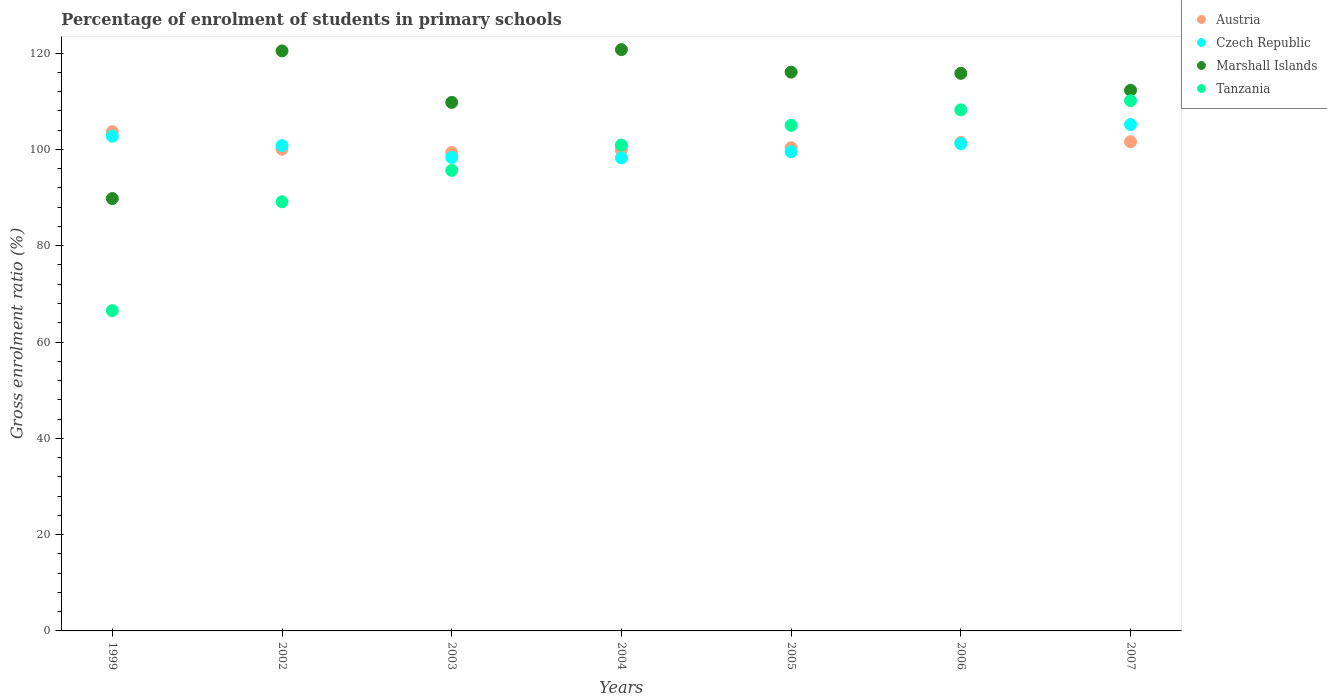Is the number of dotlines equal to the number of legend labels?
Offer a terse response. Yes. What is the percentage of students enrolled in primary schools in Czech Republic in 2004?
Make the answer very short. 98.23. Across all years, what is the maximum percentage of students enrolled in primary schools in Czech Republic?
Keep it short and to the point. 105.16. Across all years, what is the minimum percentage of students enrolled in primary schools in Czech Republic?
Your answer should be compact. 98.23. In which year was the percentage of students enrolled in primary schools in Czech Republic minimum?
Your response must be concise. 2004. What is the total percentage of students enrolled in primary schools in Tanzania in the graph?
Offer a terse response. 675.5. What is the difference between the percentage of students enrolled in primary schools in Austria in 2003 and that in 2006?
Offer a terse response. -2.08. What is the difference between the percentage of students enrolled in primary schools in Czech Republic in 2002 and the percentage of students enrolled in primary schools in Austria in 2005?
Keep it short and to the point. 0.46. What is the average percentage of students enrolled in primary schools in Tanzania per year?
Your answer should be compact. 96.5. In the year 2003, what is the difference between the percentage of students enrolled in primary schools in Austria and percentage of students enrolled in primary schools in Tanzania?
Offer a very short reply. 3.71. In how many years, is the percentage of students enrolled in primary schools in Czech Republic greater than 28 %?
Your answer should be very brief. 7. What is the ratio of the percentage of students enrolled in primary schools in Austria in 2005 to that in 2007?
Provide a short and direct response. 0.99. Is the difference between the percentage of students enrolled in primary schools in Austria in 2002 and 2007 greater than the difference between the percentage of students enrolled in primary schools in Tanzania in 2002 and 2007?
Ensure brevity in your answer.  Yes. What is the difference between the highest and the second highest percentage of students enrolled in primary schools in Tanzania?
Make the answer very short. 1.91. What is the difference between the highest and the lowest percentage of students enrolled in primary schools in Marshall Islands?
Your answer should be compact. 30.93. Is the sum of the percentage of students enrolled in primary schools in Tanzania in 2003 and 2004 greater than the maximum percentage of students enrolled in primary schools in Czech Republic across all years?
Ensure brevity in your answer.  Yes. Is it the case that in every year, the sum of the percentage of students enrolled in primary schools in Tanzania and percentage of students enrolled in primary schools in Austria  is greater than the sum of percentage of students enrolled in primary schools in Marshall Islands and percentage of students enrolled in primary schools in Czech Republic?
Offer a very short reply. No. Is it the case that in every year, the sum of the percentage of students enrolled in primary schools in Tanzania and percentage of students enrolled in primary schools in Austria  is greater than the percentage of students enrolled in primary schools in Czech Republic?
Make the answer very short. Yes. Does the percentage of students enrolled in primary schools in Czech Republic monotonically increase over the years?
Keep it short and to the point. No. Is the percentage of students enrolled in primary schools in Austria strictly greater than the percentage of students enrolled in primary schools in Marshall Islands over the years?
Ensure brevity in your answer.  No. Is the percentage of students enrolled in primary schools in Marshall Islands strictly less than the percentage of students enrolled in primary schools in Czech Republic over the years?
Ensure brevity in your answer.  No. How many dotlines are there?
Ensure brevity in your answer.  4. How many years are there in the graph?
Keep it short and to the point. 7. Are the values on the major ticks of Y-axis written in scientific E-notation?
Offer a terse response. No. Does the graph contain any zero values?
Provide a succinct answer. No. How many legend labels are there?
Make the answer very short. 4. What is the title of the graph?
Keep it short and to the point. Percentage of enrolment of students in primary schools. Does "Dominican Republic" appear as one of the legend labels in the graph?
Give a very brief answer. No. What is the label or title of the Y-axis?
Your answer should be very brief. Gross enrolment ratio (%). What is the Gross enrolment ratio (%) of Austria in 1999?
Give a very brief answer. 103.67. What is the Gross enrolment ratio (%) in Czech Republic in 1999?
Keep it short and to the point. 102.74. What is the Gross enrolment ratio (%) of Marshall Islands in 1999?
Make the answer very short. 89.79. What is the Gross enrolment ratio (%) of Tanzania in 1999?
Keep it short and to the point. 66.51. What is the Gross enrolment ratio (%) of Austria in 2002?
Your response must be concise. 100.04. What is the Gross enrolment ratio (%) in Czech Republic in 2002?
Provide a short and direct response. 100.79. What is the Gross enrolment ratio (%) in Marshall Islands in 2002?
Give a very brief answer. 120.45. What is the Gross enrolment ratio (%) in Tanzania in 2002?
Give a very brief answer. 89.12. What is the Gross enrolment ratio (%) in Austria in 2003?
Your response must be concise. 99.35. What is the Gross enrolment ratio (%) in Czech Republic in 2003?
Provide a short and direct response. 98.32. What is the Gross enrolment ratio (%) in Marshall Islands in 2003?
Your response must be concise. 109.76. What is the Gross enrolment ratio (%) in Tanzania in 2003?
Offer a very short reply. 95.65. What is the Gross enrolment ratio (%) of Austria in 2004?
Offer a very short reply. 99.85. What is the Gross enrolment ratio (%) of Czech Republic in 2004?
Ensure brevity in your answer.  98.23. What is the Gross enrolment ratio (%) of Marshall Islands in 2004?
Give a very brief answer. 120.72. What is the Gross enrolment ratio (%) of Tanzania in 2004?
Your answer should be very brief. 100.91. What is the Gross enrolment ratio (%) in Austria in 2005?
Ensure brevity in your answer.  100.33. What is the Gross enrolment ratio (%) of Czech Republic in 2005?
Offer a very short reply. 99.52. What is the Gross enrolment ratio (%) in Marshall Islands in 2005?
Make the answer very short. 116.05. What is the Gross enrolment ratio (%) of Tanzania in 2005?
Keep it short and to the point. 104.99. What is the Gross enrolment ratio (%) in Austria in 2006?
Your answer should be very brief. 101.43. What is the Gross enrolment ratio (%) of Czech Republic in 2006?
Your answer should be compact. 101.2. What is the Gross enrolment ratio (%) in Marshall Islands in 2006?
Ensure brevity in your answer.  115.79. What is the Gross enrolment ratio (%) of Tanzania in 2006?
Your answer should be very brief. 108.21. What is the Gross enrolment ratio (%) in Austria in 2007?
Ensure brevity in your answer.  101.59. What is the Gross enrolment ratio (%) of Czech Republic in 2007?
Keep it short and to the point. 105.16. What is the Gross enrolment ratio (%) in Marshall Islands in 2007?
Offer a terse response. 112.27. What is the Gross enrolment ratio (%) in Tanzania in 2007?
Provide a short and direct response. 110.12. Across all years, what is the maximum Gross enrolment ratio (%) in Austria?
Ensure brevity in your answer.  103.67. Across all years, what is the maximum Gross enrolment ratio (%) of Czech Republic?
Provide a short and direct response. 105.16. Across all years, what is the maximum Gross enrolment ratio (%) of Marshall Islands?
Give a very brief answer. 120.72. Across all years, what is the maximum Gross enrolment ratio (%) in Tanzania?
Offer a terse response. 110.12. Across all years, what is the minimum Gross enrolment ratio (%) of Austria?
Your response must be concise. 99.35. Across all years, what is the minimum Gross enrolment ratio (%) in Czech Republic?
Offer a terse response. 98.23. Across all years, what is the minimum Gross enrolment ratio (%) of Marshall Islands?
Your answer should be very brief. 89.79. Across all years, what is the minimum Gross enrolment ratio (%) in Tanzania?
Keep it short and to the point. 66.51. What is the total Gross enrolment ratio (%) of Austria in the graph?
Offer a very short reply. 706.27. What is the total Gross enrolment ratio (%) in Czech Republic in the graph?
Provide a succinct answer. 705.97. What is the total Gross enrolment ratio (%) of Marshall Islands in the graph?
Your response must be concise. 784.84. What is the total Gross enrolment ratio (%) in Tanzania in the graph?
Provide a short and direct response. 675.5. What is the difference between the Gross enrolment ratio (%) of Austria in 1999 and that in 2002?
Offer a very short reply. 3.63. What is the difference between the Gross enrolment ratio (%) in Czech Republic in 1999 and that in 2002?
Offer a terse response. 1.95. What is the difference between the Gross enrolment ratio (%) of Marshall Islands in 1999 and that in 2002?
Keep it short and to the point. -30.66. What is the difference between the Gross enrolment ratio (%) in Tanzania in 1999 and that in 2002?
Provide a short and direct response. -22.62. What is the difference between the Gross enrolment ratio (%) in Austria in 1999 and that in 2003?
Make the answer very short. 4.32. What is the difference between the Gross enrolment ratio (%) of Czech Republic in 1999 and that in 2003?
Offer a very short reply. 4.42. What is the difference between the Gross enrolment ratio (%) of Marshall Islands in 1999 and that in 2003?
Your answer should be very brief. -19.97. What is the difference between the Gross enrolment ratio (%) of Tanzania in 1999 and that in 2003?
Offer a terse response. -29.14. What is the difference between the Gross enrolment ratio (%) of Austria in 1999 and that in 2004?
Your answer should be compact. 3.82. What is the difference between the Gross enrolment ratio (%) in Czech Republic in 1999 and that in 2004?
Keep it short and to the point. 4.51. What is the difference between the Gross enrolment ratio (%) in Marshall Islands in 1999 and that in 2004?
Provide a short and direct response. -30.93. What is the difference between the Gross enrolment ratio (%) in Tanzania in 1999 and that in 2004?
Your answer should be very brief. -34.4. What is the difference between the Gross enrolment ratio (%) of Austria in 1999 and that in 2005?
Your response must be concise. 3.34. What is the difference between the Gross enrolment ratio (%) of Czech Republic in 1999 and that in 2005?
Your response must be concise. 3.22. What is the difference between the Gross enrolment ratio (%) in Marshall Islands in 1999 and that in 2005?
Your response must be concise. -26.26. What is the difference between the Gross enrolment ratio (%) of Tanzania in 1999 and that in 2005?
Provide a short and direct response. -38.49. What is the difference between the Gross enrolment ratio (%) of Austria in 1999 and that in 2006?
Your answer should be very brief. 2.24. What is the difference between the Gross enrolment ratio (%) in Czech Republic in 1999 and that in 2006?
Make the answer very short. 1.55. What is the difference between the Gross enrolment ratio (%) of Marshall Islands in 1999 and that in 2006?
Ensure brevity in your answer.  -26. What is the difference between the Gross enrolment ratio (%) in Tanzania in 1999 and that in 2006?
Provide a short and direct response. -41.7. What is the difference between the Gross enrolment ratio (%) in Austria in 1999 and that in 2007?
Make the answer very short. 2.08. What is the difference between the Gross enrolment ratio (%) in Czech Republic in 1999 and that in 2007?
Provide a short and direct response. -2.42. What is the difference between the Gross enrolment ratio (%) in Marshall Islands in 1999 and that in 2007?
Provide a short and direct response. -22.48. What is the difference between the Gross enrolment ratio (%) of Tanzania in 1999 and that in 2007?
Make the answer very short. -43.61. What is the difference between the Gross enrolment ratio (%) of Austria in 2002 and that in 2003?
Your response must be concise. 0.69. What is the difference between the Gross enrolment ratio (%) of Czech Republic in 2002 and that in 2003?
Your answer should be very brief. 2.47. What is the difference between the Gross enrolment ratio (%) of Marshall Islands in 2002 and that in 2003?
Your response must be concise. 10.69. What is the difference between the Gross enrolment ratio (%) of Tanzania in 2002 and that in 2003?
Give a very brief answer. -6.52. What is the difference between the Gross enrolment ratio (%) in Austria in 2002 and that in 2004?
Make the answer very short. 0.19. What is the difference between the Gross enrolment ratio (%) of Czech Republic in 2002 and that in 2004?
Give a very brief answer. 2.56. What is the difference between the Gross enrolment ratio (%) in Marshall Islands in 2002 and that in 2004?
Ensure brevity in your answer.  -0.27. What is the difference between the Gross enrolment ratio (%) in Tanzania in 2002 and that in 2004?
Make the answer very short. -11.78. What is the difference between the Gross enrolment ratio (%) of Austria in 2002 and that in 2005?
Give a very brief answer. -0.29. What is the difference between the Gross enrolment ratio (%) in Czech Republic in 2002 and that in 2005?
Keep it short and to the point. 1.27. What is the difference between the Gross enrolment ratio (%) in Marshall Islands in 2002 and that in 2005?
Make the answer very short. 4.4. What is the difference between the Gross enrolment ratio (%) in Tanzania in 2002 and that in 2005?
Keep it short and to the point. -15.87. What is the difference between the Gross enrolment ratio (%) of Austria in 2002 and that in 2006?
Provide a short and direct response. -1.39. What is the difference between the Gross enrolment ratio (%) of Czech Republic in 2002 and that in 2006?
Give a very brief answer. -0.41. What is the difference between the Gross enrolment ratio (%) of Marshall Islands in 2002 and that in 2006?
Provide a succinct answer. 4.66. What is the difference between the Gross enrolment ratio (%) of Tanzania in 2002 and that in 2006?
Provide a succinct answer. -19.08. What is the difference between the Gross enrolment ratio (%) of Austria in 2002 and that in 2007?
Keep it short and to the point. -1.55. What is the difference between the Gross enrolment ratio (%) of Czech Republic in 2002 and that in 2007?
Offer a very short reply. -4.37. What is the difference between the Gross enrolment ratio (%) of Marshall Islands in 2002 and that in 2007?
Keep it short and to the point. 8.18. What is the difference between the Gross enrolment ratio (%) of Tanzania in 2002 and that in 2007?
Provide a succinct answer. -21. What is the difference between the Gross enrolment ratio (%) of Austria in 2003 and that in 2004?
Make the answer very short. -0.5. What is the difference between the Gross enrolment ratio (%) of Czech Republic in 2003 and that in 2004?
Provide a succinct answer. 0.09. What is the difference between the Gross enrolment ratio (%) in Marshall Islands in 2003 and that in 2004?
Give a very brief answer. -10.96. What is the difference between the Gross enrolment ratio (%) in Tanzania in 2003 and that in 2004?
Provide a succinct answer. -5.26. What is the difference between the Gross enrolment ratio (%) of Austria in 2003 and that in 2005?
Ensure brevity in your answer.  -0.98. What is the difference between the Gross enrolment ratio (%) of Czech Republic in 2003 and that in 2005?
Offer a terse response. -1.2. What is the difference between the Gross enrolment ratio (%) of Marshall Islands in 2003 and that in 2005?
Give a very brief answer. -6.29. What is the difference between the Gross enrolment ratio (%) of Tanzania in 2003 and that in 2005?
Your response must be concise. -9.35. What is the difference between the Gross enrolment ratio (%) in Austria in 2003 and that in 2006?
Offer a terse response. -2.08. What is the difference between the Gross enrolment ratio (%) of Czech Republic in 2003 and that in 2006?
Your response must be concise. -2.87. What is the difference between the Gross enrolment ratio (%) of Marshall Islands in 2003 and that in 2006?
Your answer should be very brief. -6.03. What is the difference between the Gross enrolment ratio (%) of Tanzania in 2003 and that in 2006?
Offer a terse response. -12.56. What is the difference between the Gross enrolment ratio (%) in Austria in 2003 and that in 2007?
Ensure brevity in your answer.  -2.23. What is the difference between the Gross enrolment ratio (%) in Czech Republic in 2003 and that in 2007?
Ensure brevity in your answer.  -6.84. What is the difference between the Gross enrolment ratio (%) in Marshall Islands in 2003 and that in 2007?
Your answer should be compact. -2.51. What is the difference between the Gross enrolment ratio (%) of Tanzania in 2003 and that in 2007?
Make the answer very short. -14.47. What is the difference between the Gross enrolment ratio (%) of Austria in 2004 and that in 2005?
Provide a short and direct response. -0.48. What is the difference between the Gross enrolment ratio (%) of Czech Republic in 2004 and that in 2005?
Keep it short and to the point. -1.29. What is the difference between the Gross enrolment ratio (%) in Marshall Islands in 2004 and that in 2005?
Ensure brevity in your answer.  4.67. What is the difference between the Gross enrolment ratio (%) of Tanzania in 2004 and that in 2005?
Your response must be concise. -4.09. What is the difference between the Gross enrolment ratio (%) in Austria in 2004 and that in 2006?
Ensure brevity in your answer.  -1.58. What is the difference between the Gross enrolment ratio (%) of Czech Republic in 2004 and that in 2006?
Give a very brief answer. -2.97. What is the difference between the Gross enrolment ratio (%) in Marshall Islands in 2004 and that in 2006?
Ensure brevity in your answer.  4.93. What is the difference between the Gross enrolment ratio (%) of Tanzania in 2004 and that in 2006?
Your answer should be compact. -7.3. What is the difference between the Gross enrolment ratio (%) of Austria in 2004 and that in 2007?
Your answer should be compact. -1.73. What is the difference between the Gross enrolment ratio (%) of Czech Republic in 2004 and that in 2007?
Your answer should be compact. -6.93. What is the difference between the Gross enrolment ratio (%) of Marshall Islands in 2004 and that in 2007?
Provide a succinct answer. 8.45. What is the difference between the Gross enrolment ratio (%) of Tanzania in 2004 and that in 2007?
Make the answer very short. -9.21. What is the difference between the Gross enrolment ratio (%) of Austria in 2005 and that in 2006?
Make the answer very short. -1.1. What is the difference between the Gross enrolment ratio (%) of Czech Republic in 2005 and that in 2006?
Keep it short and to the point. -1.68. What is the difference between the Gross enrolment ratio (%) in Marshall Islands in 2005 and that in 2006?
Provide a short and direct response. 0.26. What is the difference between the Gross enrolment ratio (%) in Tanzania in 2005 and that in 2006?
Make the answer very short. -3.21. What is the difference between the Gross enrolment ratio (%) of Austria in 2005 and that in 2007?
Offer a terse response. -1.25. What is the difference between the Gross enrolment ratio (%) of Czech Republic in 2005 and that in 2007?
Keep it short and to the point. -5.64. What is the difference between the Gross enrolment ratio (%) of Marshall Islands in 2005 and that in 2007?
Your response must be concise. 3.78. What is the difference between the Gross enrolment ratio (%) in Tanzania in 2005 and that in 2007?
Give a very brief answer. -5.13. What is the difference between the Gross enrolment ratio (%) of Austria in 2006 and that in 2007?
Your response must be concise. -0.15. What is the difference between the Gross enrolment ratio (%) of Czech Republic in 2006 and that in 2007?
Make the answer very short. -3.96. What is the difference between the Gross enrolment ratio (%) of Marshall Islands in 2006 and that in 2007?
Your answer should be compact. 3.52. What is the difference between the Gross enrolment ratio (%) of Tanzania in 2006 and that in 2007?
Give a very brief answer. -1.91. What is the difference between the Gross enrolment ratio (%) in Austria in 1999 and the Gross enrolment ratio (%) in Czech Republic in 2002?
Provide a short and direct response. 2.88. What is the difference between the Gross enrolment ratio (%) of Austria in 1999 and the Gross enrolment ratio (%) of Marshall Islands in 2002?
Provide a succinct answer. -16.78. What is the difference between the Gross enrolment ratio (%) in Austria in 1999 and the Gross enrolment ratio (%) in Tanzania in 2002?
Your response must be concise. 14.55. What is the difference between the Gross enrolment ratio (%) in Czech Republic in 1999 and the Gross enrolment ratio (%) in Marshall Islands in 2002?
Your response must be concise. -17.71. What is the difference between the Gross enrolment ratio (%) of Czech Republic in 1999 and the Gross enrolment ratio (%) of Tanzania in 2002?
Give a very brief answer. 13.62. What is the difference between the Gross enrolment ratio (%) of Marshall Islands in 1999 and the Gross enrolment ratio (%) of Tanzania in 2002?
Your answer should be very brief. 0.67. What is the difference between the Gross enrolment ratio (%) in Austria in 1999 and the Gross enrolment ratio (%) in Czech Republic in 2003?
Your answer should be very brief. 5.35. What is the difference between the Gross enrolment ratio (%) in Austria in 1999 and the Gross enrolment ratio (%) in Marshall Islands in 2003?
Your response must be concise. -6.09. What is the difference between the Gross enrolment ratio (%) of Austria in 1999 and the Gross enrolment ratio (%) of Tanzania in 2003?
Keep it short and to the point. 8.03. What is the difference between the Gross enrolment ratio (%) in Czech Republic in 1999 and the Gross enrolment ratio (%) in Marshall Islands in 2003?
Your answer should be very brief. -7.02. What is the difference between the Gross enrolment ratio (%) in Czech Republic in 1999 and the Gross enrolment ratio (%) in Tanzania in 2003?
Provide a succinct answer. 7.1. What is the difference between the Gross enrolment ratio (%) in Marshall Islands in 1999 and the Gross enrolment ratio (%) in Tanzania in 2003?
Offer a very short reply. -5.85. What is the difference between the Gross enrolment ratio (%) in Austria in 1999 and the Gross enrolment ratio (%) in Czech Republic in 2004?
Offer a very short reply. 5.44. What is the difference between the Gross enrolment ratio (%) in Austria in 1999 and the Gross enrolment ratio (%) in Marshall Islands in 2004?
Provide a short and direct response. -17.05. What is the difference between the Gross enrolment ratio (%) of Austria in 1999 and the Gross enrolment ratio (%) of Tanzania in 2004?
Your answer should be compact. 2.76. What is the difference between the Gross enrolment ratio (%) of Czech Republic in 1999 and the Gross enrolment ratio (%) of Marshall Islands in 2004?
Offer a very short reply. -17.98. What is the difference between the Gross enrolment ratio (%) of Czech Republic in 1999 and the Gross enrolment ratio (%) of Tanzania in 2004?
Make the answer very short. 1.84. What is the difference between the Gross enrolment ratio (%) of Marshall Islands in 1999 and the Gross enrolment ratio (%) of Tanzania in 2004?
Provide a succinct answer. -11.11. What is the difference between the Gross enrolment ratio (%) of Austria in 1999 and the Gross enrolment ratio (%) of Czech Republic in 2005?
Make the answer very short. 4.15. What is the difference between the Gross enrolment ratio (%) of Austria in 1999 and the Gross enrolment ratio (%) of Marshall Islands in 2005?
Offer a very short reply. -12.38. What is the difference between the Gross enrolment ratio (%) in Austria in 1999 and the Gross enrolment ratio (%) in Tanzania in 2005?
Your answer should be compact. -1.32. What is the difference between the Gross enrolment ratio (%) of Czech Republic in 1999 and the Gross enrolment ratio (%) of Marshall Islands in 2005?
Keep it short and to the point. -13.31. What is the difference between the Gross enrolment ratio (%) of Czech Republic in 1999 and the Gross enrolment ratio (%) of Tanzania in 2005?
Keep it short and to the point. -2.25. What is the difference between the Gross enrolment ratio (%) of Marshall Islands in 1999 and the Gross enrolment ratio (%) of Tanzania in 2005?
Make the answer very short. -15.2. What is the difference between the Gross enrolment ratio (%) in Austria in 1999 and the Gross enrolment ratio (%) in Czech Republic in 2006?
Your answer should be very brief. 2.47. What is the difference between the Gross enrolment ratio (%) of Austria in 1999 and the Gross enrolment ratio (%) of Marshall Islands in 2006?
Ensure brevity in your answer.  -12.12. What is the difference between the Gross enrolment ratio (%) of Austria in 1999 and the Gross enrolment ratio (%) of Tanzania in 2006?
Your answer should be compact. -4.54. What is the difference between the Gross enrolment ratio (%) of Czech Republic in 1999 and the Gross enrolment ratio (%) of Marshall Islands in 2006?
Make the answer very short. -13.05. What is the difference between the Gross enrolment ratio (%) in Czech Republic in 1999 and the Gross enrolment ratio (%) in Tanzania in 2006?
Your answer should be compact. -5.46. What is the difference between the Gross enrolment ratio (%) in Marshall Islands in 1999 and the Gross enrolment ratio (%) in Tanzania in 2006?
Give a very brief answer. -18.41. What is the difference between the Gross enrolment ratio (%) in Austria in 1999 and the Gross enrolment ratio (%) in Czech Republic in 2007?
Your answer should be compact. -1.49. What is the difference between the Gross enrolment ratio (%) in Austria in 1999 and the Gross enrolment ratio (%) in Marshall Islands in 2007?
Provide a succinct answer. -8.6. What is the difference between the Gross enrolment ratio (%) in Austria in 1999 and the Gross enrolment ratio (%) in Tanzania in 2007?
Your answer should be compact. -6.45. What is the difference between the Gross enrolment ratio (%) of Czech Republic in 1999 and the Gross enrolment ratio (%) of Marshall Islands in 2007?
Give a very brief answer. -9.53. What is the difference between the Gross enrolment ratio (%) of Czech Republic in 1999 and the Gross enrolment ratio (%) of Tanzania in 2007?
Ensure brevity in your answer.  -7.37. What is the difference between the Gross enrolment ratio (%) of Marshall Islands in 1999 and the Gross enrolment ratio (%) of Tanzania in 2007?
Your answer should be compact. -20.32. What is the difference between the Gross enrolment ratio (%) of Austria in 2002 and the Gross enrolment ratio (%) of Czech Republic in 2003?
Your answer should be very brief. 1.72. What is the difference between the Gross enrolment ratio (%) in Austria in 2002 and the Gross enrolment ratio (%) in Marshall Islands in 2003?
Your answer should be compact. -9.72. What is the difference between the Gross enrolment ratio (%) in Austria in 2002 and the Gross enrolment ratio (%) in Tanzania in 2003?
Give a very brief answer. 4.39. What is the difference between the Gross enrolment ratio (%) of Czech Republic in 2002 and the Gross enrolment ratio (%) of Marshall Islands in 2003?
Your answer should be compact. -8.97. What is the difference between the Gross enrolment ratio (%) of Czech Republic in 2002 and the Gross enrolment ratio (%) of Tanzania in 2003?
Offer a very short reply. 5.14. What is the difference between the Gross enrolment ratio (%) of Marshall Islands in 2002 and the Gross enrolment ratio (%) of Tanzania in 2003?
Offer a very short reply. 24.81. What is the difference between the Gross enrolment ratio (%) in Austria in 2002 and the Gross enrolment ratio (%) in Czech Republic in 2004?
Provide a short and direct response. 1.81. What is the difference between the Gross enrolment ratio (%) of Austria in 2002 and the Gross enrolment ratio (%) of Marshall Islands in 2004?
Provide a succinct answer. -20.68. What is the difference between the Gross enrolment ratio (%) of Austria in 2002 and the Gross enrolment ratio (%) of Tanzania in 2004?
Provide a succinct answer. -0.87. What is the difference between the Gross enrolment ratio (%) of Czech Republic in 2002 and the Gross enrolment ratio (%) of Marshall Islands in 2004?
Make the answer very short. -19.93. What is the difference between the Gross enrolment ratio (%) in Czech Republic in 2002 and the Gross enrolment ratio (%) in Tanzania in 2004?
Your response must be concise. -0.12. What is the difference between the Gross enrolment ratio (%) of Marshall Islands in 2002 and the Gross enrolment ratio (%) of Tanzania in 2004?
Offer a very short reply. 19.55. What is the difference between the Gross enrolment ratio (%) in Austria in 2002 and the Gross enrolment ratio (%) in Czech Republic in 2005?
Your answer should be compact. 0.52. What is the difference between the Gross enrolment ratio (%) in Austria in 2002 and the Gross enrolment ratio (%) in Marshall Islands in 2005?
Keep it short and to the point. -16.01. What is the difference between the Gross enrolment ratio (%) of Austria in 2002 and the Gross enrolment ratio (%) of Tanzania in 2005?
Provide a short and direct response. -4.95. What is the difference between the Gross enrolment ratio (%) in Czech Republic in 2002 and the Gross enrolment ratio (%) in Marshall Islands in 2005?
Provide a succinct answer. -15.26. What is the difference between the Gross enrolment ratio (%) in Czech Republic in 2002 and the Gross enrolment ratio (%) in Tanzania in 2005?
Offer a very short reply. -4.2. What is the difference between the Gross enrolment ratio (%) of Marshall Islands in 2002 and the Gross enrolment ratio (%) of Tanzania in 2005?
Give a very brief answer. 15.46. What is the difference between the Gross enrolment ratio (%) of Austria in 2002 and the Gross enrolment ratio (%) of Czech Republic in 2006?
Offer a very short reply. -1.16. What is the difference between the Gross enrolment ratio (%) in Austria in 2002 and the Gross enrolment ratio (%) in Marshall Islands in 2006?
Your response must be concise. -15.75. What is the difference between the Gross enrolment ratio (%) in Austria in 2002 and the Gross enrolment ratio (%) in Tanzania in 2006?
Keep it short and to the point. -8.17. What is the difference between the Gross enrolment ratio (%) in Czech Republic in 2002 and the Gross enrolment ratio (%) in Marshall Islands in 2006?
Offer a very short reply. -15. What is the difference between the Gross enrolment ratio (%) of Czech Republic in 2002 and the Gross enrolment ratio (%) of Tanzania in 2006?
Your answer should be very brief. -7.42. What is the difference between the Gross enrolment ratio (%) of Marshall Islands in 2002 and the Gross enrolment ratio (%) of Tanzania in 2006?
Your answer should be very brief. 12.25. What is the difference between the Gross enrolment ratio (%) of Austria in 2002 and the Gross enrolment ratio (%) of Czech Republic in 2007?
Offer a terse response. -5.12. What is the difference between the Gross enrolment ratio (%) of Austria in 2002 and the Gross enrolment ratio (%) of Marshall Islands in 2007?
Keep it short and to the point. -12.23. What is the difference between the Gross enrolment ratio (%) in Austria in 2002 and the Gross enrolment ratio (%) in Tanzania in 2007?
Make the answer very short. -10.08. What is the difference between the Gross enrolment ratio (%) of Czech Republic in 2002 and the Gross enrolment ratio (%) of Marshall Islands in 2007?
Make the answer very short. -11.48. What is the difference between the Gross enrolment ratio (%) of Czech Republic in 2002 and the Gross enrolment ratio (%) of Tanzania in 2007?
Provide a short and direct response. -9.33. What is the difference between the Gross enrolment ratio (%) of Marshall Islands in 2002 and the Gross enrolment ratio (%) of Tanzania in 2007?
Your answer should be compact. 10.34. What is the difference between the Gross enrolment ratio (%) in Austria in 2003 and the Gross enrolment ratio (%) in Czech Republic in 2004?
Your answer should be compact. 1.12. What is the difference between the Gross enrolment ratio (%) of Austria in 2003 and the Gross enrolment ratio (%) of Marshall Islands in 2004?
Your answer should be compact. -21.37. What is the difference between the Gross enrolment ratio (%) of Austria in 2003 and the Gross enrolment ratio (%) of Tanzania in 2004?
Offer a terse response. -1.55. What is the difference between the Gross enrolment ratio (%) of Czech Republic in 2003 and the Gross enrolment ratio (%) of Marshall Islands in 2004?
Provide a short and direct response. -22.4. What is the difference between the Gross enrolment ratio (%) of Czech Republic in 2003 and the Gross enrolment ratio (%) of Tanzania in 2004?
Offer a terse response. -2.58. What is the difference between the Gross enrolment ratio (%) in Marshall Islands in 2003 and the Gross enrolment ratio (%) in Tanzania in 2004?
Keep it short and to the point. 8.85. What is the difference between the Gross enrolment ratio (%) of Austria in 2003 and the Gross enrolment ratio (%) of Czech Republic in 2005?
Provide a succinct answer. -0.17. What is the difference between the Gross enrolment ratio (%) of Austria in 2003 and the Gross enrolment ratio (%) of Marshall Islands in 2005?
Offer a terse response. -16.7. What is the difference between the Gross enrolment ratio (%) in Austria in 2003 and the Gross enrolment ratio (%) in Tanzania in 2005?
Keep it short and to the point. -5.64. What is the difference between the Gross enrolment ratio (%) in Czech Republic in 2003 and the Gross enrolment ratio (%) in Marshall Islands in 2005?
Your answer should be compact. -17.73. What is the difference between the Gross enrolment ratio (%) in Czech Republic in 2003 and the Gross enrolment ratio (%) in Tanzania in 2005?
Provide a succinct answer. -6.67. What is the difference between the Gross enrolment ratio (%) of Marshall Islands in 2003 and the Gross enrolment ratio (%) of Tanzania in 2005?
Make the answer very short. 4.77. What is the difference between the Gross enrolment ratio (%) in Austria in 2003 and the Gross enrolment ratio (%) in Czech Republic in 2006?
Give a very brief answer. -1.84. What is the difference between the Gross enrolment ratio (%) in Austria in 2003 and the Gross enrolment ratio (%) in Marshall Islands in 2006?
Give a very brief answer. -16.44. What is the difference between the Gross enrolment ratio (%) in Austria in 2003 and the Gross enrolment ratio (%) in Tanzania in 2006?
Your response must be concise. -8.85. What is the difference between the Gross enrolment ratio (%) of Czech Republic in 2003 and the Gross enrolment ratio (%) of Marshall Islands in 2006?
Give a very brief answer. -17.47. What is the difference between the Gross enrolment ratio (%) of Czech Republic in 2003 and the Gross enrolment ratio (%) of Tanzania in 2006?
Your answer should be compact. -9.88. What is the difference between the Gross enrolment ratio (%) of Marshall Islands in 2003 and the Gross enrolment ratio (%) of Tanzania in 2006?
Keep it short and to the point. 1.55. What is the difference between the Gross enrolment ratio (%) in Austria in 2003 and the Gross enrolment ratio (%) in Czech Republic in 2007?
Give a very brief answer. -5.81. What is the difference between the Gross enrolment ratio (%) of Austria in 2003 and the Gross enrolment ratio (%) of Marshall Islands in 2007?
Provide a short and direct response. -12.92. What is the difference between the Gross enrolment ratio (%) of Austria in 2003 and the Gross enrolment ratio (%) of Tanzania in 2007?
Offer a terse response. -10.77. What is the difference between the Gross enrolment ratio (%) in Czech Republic in 2003 and the Gross enrolment ratio (%) in Marshall Islands in 2007?
Offer a very short reply. -13.95. What is the difference between the Gross enrolment ratio (%) in Czech Republic in 2003 and the Gross enrolment ratio (%) in Tanzania in 2007?
Provide a short and direct response. -11.8. What is the difference between the Gross enrolment ratio (%) of Marshall Islands in 2003 and the Gross enrolment ratio (%) of Tanzania in 2007?
Offer a terse response. -0.36. What is the difference between the Gross enrolment ratio (%) of Austria in 2004 and the Gross enrolment ratio (%) of Czech Republic in 2005?
Your response must be concise. 0.33. What is the difference between the Gross enrolment ratio (%) in Austria in 2004 and the Gross enrolment ratio (%) in Marshall Islands in 2005?
Your answer should be very brief. -16.2. What is the difference between the Gross enrolment ratio (%) of Austria in 2004 and the Gross enrolment ratio (%) of Tanzania in 2005?
Ensure brevity in your answer.  -5.14. What is the difference between the Gross enrolment ratio (%) in Czech Republic in 2004 and the Gross enrolment ratio (%) in Marshall Islands in 2005?
Keep it short and to the point. -17.82. What is the difference between the Gross enrolment ratio (%) in Czech Republic in 2004 and the Gross enrolment ratio (%) in Tanzania in 2005?
Your answer should be very brief. -6.76. What is the difference between the Gross enrolment ratio (%) in Marshall Islands in 2004 and the Gross enrolment ratio (%) in Tanzania in 2005?
Offer a terse response. 15.73. What is the difference between the Gross enrolment ratio (%) in Austria in 2004 and the Gross enrolment ratio (%) in Czech Republic in 2006?
Ensure brevity in your answer.  -1.34. What is the difference between the Gross enrolment ratio (%) of Austria in 2004 and the Gross enrolment ratio (%) of Marshall Islands in 2006?
Your response must be concise. -15.94. What is the difference between the Gross enrolment ratio (%) of Austria in 2004 and the Gross enrolment ratio (%) of Tanzania in 2006?
Give a very brief answer. -8.35. What is the difference between the Gross enrolment ratio (%) of Czech Republic in 2004 and the Gross enrolment ratio (%) of Marshall Islands in 2006?
Make the answer very short. -17.56. What is the difference between the Gross enrolment ratio (%) of Czech Republic in 2004 and the Gross enrolment ratio (%) of Tanzania in 2006?
Your answer should be very brief. -9.98. What is the difference between the Gross enrolment ratio (%) in Marshall Islands in 2004 and the Gross enrolment ratio (%) in Tanzania in 2006?
Give a very brief answer. 12.51. What is the difference between the Gross enrolment ratio (%) in Austria in 2004 and the Gross enrolment ratio (%) in Czech Republic in 2007?
Offer a very short reply. -5.31. What is the difference between the Gross enrolment ratio (%) of Austria in 2004 and the Gross enrolment ratio (%) of Marshall Islands in 2007?
Make the answer very short. -12.42. What is the difference between the Gross enrolment ratio (%) of Austria in 2004 and the Gross enrolment ratio (%) of Tanzania in 2007?
Give a very brief answer. -10.26. What is the difference between the Gross enrolment ratio (%) in Czech Republic in 2004 and the Gross enrolment ratio (%) in Marshall Islands in 2007?
Give a very brief answer. -14.04. What is the difference between the Gross enrolment ratio (%) in Czech Republic in 2004 and the Gross enrolment ratio (%) in Tanzania in 2007?
Your answer should be very brief. -11.89. What is the difference between the Gross enrolment ratio (%) of Marshall Islands in 2004 and the Gross enrolment ratio (%) of Tanzania in 2007?
Ensure brevity in your answer.  10.6. What is the difference between the Gross enrolment ratio (%) in Austria in 2005 and the Gross enrolment ratio (%) in Czech Republic in 2006?
Your response must be concise. -0.86. What is the difference between the Gross enrolment ratio (%) of Austria in 2005 and the Gross enrolment ratio (%) of Marshall Islands in 2006?
Offer a very short reply. -15.46. What is the difference between the Gross enrolment ratio (%) in Austria in 2005 and the Gross enrolment ratio (%) in Tanzania in 2006?
Keep it short and to the point. -7.87. What is the difference between the Gross enrolment ratio (%) of Czech Republic in 2005 and the Gross enrolment ratio (%) of Marshall Islands in 2006?
Your answer should be very brief. -16.27. What is the difference between the Gross enrolment ratio (%) in Czech Republic in 2005 and the Gross enrolment ratio (%) in Tanzania in 2006?
Keep it short and to the point. -8.69. What is the difference between the Gross enrolment ratio (%) in Marshall Islands in 2005 and the Gross enrolment ratio (%) in Tanzania in 2006?
Provide a short and direct response. 7.84. What is the difference between the Gross enrolment ratio (%) of Austria in 2005 and the Gross enrolment ratio (%) of Czech Republic in 2007?
Keep it short and to the point. -4.83. What is the difference between the Gross enrolment ratio (%) in Austria in 2005 and the Gross enrolment ratio (%) in Marshall Islands in 2007?
Keep it short and to the point. -11.94. What is the difference between the Gross enrolment ratio (%) in Austria in 2005 and the Gross enrolment ratio (%) in Tanzania in 2007?
Provide a succinct answer. -9.78. What is the difference between the Gross enrolment ratio (%) of Czech Republic in 2005 and the Gross enrolment ratio (%) of Marshall Islands in 2007?
Offer a very short reply. -12.75. What is the difference between the Gross enrolment ratio (%) of Czech Republic in 2005 and the Gross enrolment ratio (%) of Tanzania in 2007?
Your response must be concise. -10.6. What is the difference between the Gross enrolment ratio (%) of Marshall Islands in 2005 and the Gross enrolment ratio (%) of Tanzania in 2007?
Your answer should be very brief. 5.93. What is the difference between the Gross enrolment ratio (%) of Austria in 2006 and the Gross enrolment ratio (%) of Czech Republic in 2007?
Give a very brief answer. -3.73. What is the difference between the Gross enrolment ratio (%) of Austria in 2006 and the Gross enrolment ratio (%) of Marshall Islands in 2007?
Make the answer very short. -10.84. What is the difference between the Gross enrolment ratio (%) in Austria in 2006 and the Gross enrolment ratio (%) in Tanzania in 2007?
Give a very brief answer. -8.68. What is the difference between the Gross enrolment ratio (%) in Czech Republic in 2006 and the Gross enrolment ratio (%) in Marshall Islands in 2007?
Your response must be concise. -11.08. What is the difference between the Gross enrolment ratio (%) of Czech Republic in 2006 and the Gross enrolment ratio (%) of Tanzania in 2007?
Your response must be concise. -8.92. What is the difference between the Gross enrolment ratio (%) of Marshall Islands in 2006 and the Gross enrolment ratio (%) of Tanzania in 2007?
Offer a terse response. 5.68. What is the average Gross enrolment ratio (%) of Austria per year?
Give a very brief answer. 100.9. What is the average Gross enrolment ratio (%) of Czech Republic per year?
Your response must be concise. 100.85. What is the average Gross enrolment ratio (%) of Marshall Islands per year?
Ensure brevity in your answer.  112.12. What is the average Gross enrolment ratio (%) in Tanzania per year?
Offer a very short reply. 96.5. In the year 1999, what is the difference between the Gross enrolment ratio (%) of Austria and Gross enrolment ratio (%) of Czech Republic?
Offer a terse response. 0.93. In the year 1999, what is the difference between the Gross enrolment ratio (%) in Austria and Gross enrolment ratio (%) in Marshall Islands?
Ensure brevity in your answer.  13.88. In the year 1999, what is the difference between the Gross enrolment ratio (%) in Austria and Gross enrolment ratio (%) in Tanzania?
Keep it short and to the point. 37.16. In the year 1999, what is the difference between the Gross enrolment ratio (%) in Czech Republic and Gross enrolment ratio (%) in Marshall Islands?
Make the answer very short. 12.95. In the year 1999, what is the difference between the Gross enrolment ratio (%) of Czech Republic and Gross enrolment ratio (%) of Tanzania?
Give a very brief answer. 36.24. In the year 1999, what is the difference between the Gross enrolment ratio (%) in Marshall Islands and Gross enrolment ratio (%) in Tanzania?
Keep it short and to the point. 23.29. In the year 2002, what is the difference between the Gross enrolment ratio (%) in Austria and Gross enrolment ratio (%) in Czech Republic?
Give a very brief answer. -0.75. In the year 2002, what is the difference between the Gross enrolment ratio (%) in Austria and Gross enrolment ratio (%) in Marshall Islands?
Ensure brevity in your answer.  -20.41. In the year 2002, what is the difference between the Gross enrolment ratio (%) in Austria and Gross enrolment ratio (%) in Tanzania?
Offer a terse response. 10.92. In the year 2002, what is the difference between the Gross enrolment ratio (%) in Czech Republic and Gross enrolment ratio (%) in Marshall Islands?
Your response must be concise. -19.66. In the year 2002, what is the difference between the Gross enrolment ratio (%) of Czech Republic and Gross enrolment ratio (%) of Tanzania?
Keep it short and to the point. 11.67. In the year 2002, what is the difference between the Gross enrolment ratio (%) of Marshall Islands and Gross enrolment ratio (%) of Tanzania?
Your answer should be compact. 31.33. In the year 2003, what is the difference between the Gross enrolment ratio (%) of Austria and Gross enrolment ratio (%) of Czech Republic?
Provide a succinct answer. 1.03. In the year 2003, what is the difference between the Gross enrolment ratio (%) in Austria and Gross enrolment ratio (%) in Marshall Islands?
Your response must be concise. -10.41. In the year 2003, what is the difference between the Gross enrolment ratio (%) in Austria and Gross enrolment ratio (%) in Tanzania?
Ensure brevity in your answer.  3.71. In the year 2003, what is the difference between the Gross enrolment ratio (%) of Czech Republic and Gross enrolment ratio (%) of Marshall Islands?
Provide a short and direct response. -11.44. In the year 2003, what is the difference between the Gross enrolment ratio (%) in Czech Republic and Gross enrolment ratio (%) in Tanzania?
Provide a short and direct response. 2.68. In the year 2003, what is the difference between the Gross enrolment ratio (%) in Marshall Islands and Gross enrolment ratio (%) in Tanzania?
Provide a short and direct response. 14.12. In the year 2004, what is the difference between the Gross enrolment ratio (%) in Austria and Gross enrolment ratio (%) in Czech Republic?
Give a very brief answer. 1.62. In the year 2004, what is the difference between the Gross enrolment ratio (%) of Austria and Gross enrolment ratio (%) of Marshall Islands?
Offer a terse response. -20.87. In the year 2004, what is the difference between the Gross enrolment ratio (%) in Austria and Gross enrolment ratio (%) in Tanzania?
Provide a short and direct response. -1.05. In the year 2004, what is the difference between the Gross enrolment ratio (%) in Czech Republic and Gross enrolment ratio (%) in Marshall Islands?
Your answer should be compact. -22.49. In the year 2004, what is the difference between the Gross enrolment ratio (%) in Czech Republic and Gross enrolment ratio (%) in Tanzania?
Provide a short and direct response. -2.68. In the year 2004, what is the difference between the Gross enrolment ratio (%) in Marshall Islands and Gross enrolment ratio (%) in Tanzania?
Offer a very short reply. 19.81. In the year 2005, what is the difference between the Gross enrolment ratio (%) of Austria and Gross enrolment ratio (%) of Czech Republic?
Keep it short and to the point. 0.81. In the year 2005, what is the difference between the Gross enrolment ratio (%) in Austria and Gross enrolment ratio (%) in Marshall Islands?
Provide a succinct answer. -15.71. In the year 2005, what is the difference between the Gross enrolment ratio (%) of Austria and Gross enrolment ratio (%) of Tanzania?
Ensure brevity in your answer.  -4.66. In the year 2005, what is the difference between the Gross enrolment ratio (%) of Czech Republic and Gross enrolment ratio (%) of Marshall Islands?
Offer a very short reply. -16.53. In the year 2005, what is the difference between the Gross enrolment ratio (%) in Czech Republic and Gross enrolment ratio (%) in Tanzania?
Offer a very short reply. -5.47. In the year 2005, what is the difference between the Gross enrolment ratio (%) in Marshall Islands and Gross enrolment ratio (%) in Tanzania?
Make the answer very short. 11.06. In the year 2006, what is the difference between the Gross enrolment ratio (%) in Austria and Gross enrolment ratio (%) in Czech Republic?
Your response must be concise. 0.24. In the year 2006, what is the difference between the Gross enrolment ratio (%) in Austria and Gross enrolment ratio (%) in Marshall Islands?
Your response must be concise. -14.36. In the year 2006, what is the difference between the Gross enrolment ratio (%) of Austria and Gross enrolment ratio (%) of Tanzania?
Your answer should be very brief. -6.77. In the year 2006, what is the difference between the Gross enrolment ratio (%) of Czech Republic and Gross enrolment ratio (%) of Marshall Islands?
Offer a very short reply. -14.6. In the year 2006, what is the difference between the Gross enrolment ratio (%) of Czech Republic and Gross enrolment ratio (%) of Tanzania?
Give a very brief answer. -7.01. In the year 2006, what is the difference between the Gross enrolment ratio (%) in Marshall Islands and Gross enrolment ratio (%) in Tanzania?
Keep it short and to the point. 7.59. In the year 2007, what is the difference between the Gross enrolment ratio (%) in Austria and Gross enrolment ratio (%) in Czech Republic?
Your response must be concise. -3.58. In the year 2007, what is the difference between the Gross enrolment ratio (%) in Austria and Gross enrolment ratio (%) in Marshall Islands?
Offer a very short reply. -10.69. In the year 2007, what is the difference between the Gross enrolment ratio (%) of Austria and Gross enrolment ratio (%) of Tanzania?
Your response must be concise. -8.53. In the year 2007, what is the difference between the Gross enrolment ratio (%) in Czech Republic and Gross enrolment ratio (%) in Marshall Islands?
Your response must be concise. -7.11. In the year 2007, what is the difference between the Gross enrolment ratio (%) of Czech Republic and Gross enrolment ratio (%) of Tanzania?
Ensure brevity in your answer.  -4.96. In the year 2007, what is the difference between the Gross enrolment ratio (%) of Marshall Islands and Gross enrolment ratio (%) of Tanzania?
Provide a succinct answer. 2.15. What is the ratio of the Gross enrolment ratio (%) of Austria in 1999 to that in 2002?
Give a very brief answer. 1.04. What is the ratio of the Gross enrolment ratio (%) in Czech Republic in 1999 to that in 2002?
Offer a very short reply. 1.02. What is the ratio of the Gross enrolment ratio (%) in Marshall Islands in 1999 to that in 2002?
Your response must be concise. 0.75. What is the ratio of the Gross enrolment ratio (%) in Tanzania in 1999 to that in 2002?
Your answer should be compact. 0.75. What is the ratio of the Gross enrolment ratio (%) of Austria in 1999 to that in 2003?
Your answer should be compact. 1.04. What is the ratio of the Gross enrolment ratio (%) in Czech Republic in 1999 to that in 2003?
Keep it short and to the point. 1.04. What is the ratio of the Gross enrolment ratio (%) of Marshall Islands in 1999 to that in 2003?
Keep it short and to the point. 0.82. What is the ratio of the Gross enrolment ratio (%) in Tanzania in 1999 to that in 2003?
Your response must be concise. 0.7. What is the ratio of the Gross enrolment ratio (%) of Austria in 1999 to that in 2004?
Your answer should be compact. 1.04. What is the ratio of the Gross enrolment ratio (%) in Czech Republic in 1999 to that in 2004?
Provide a succinct answer. 1.05. What is the ratio of the Gross enrolment ratio (%) in Marshall Islands in 1999 to that in 2004?
Give a very brief answer. 0.74. What is the ratio of the Gross enrolment ratio (%) in Tanzania in 1999 to that in 2004?
Offer a very short reply. 0.66. What is the ratio of the Gross enrolment ratio (%) in Austria in 1999 to that in 2005?
Offer a very short reply. 1.03. What is the ratio of the Gross enrolment ratio (%) of Czech Republic in 1999 to that in 2005?
Give a very brief answer. 1.03. What is the ratio of the Gross enrolment ratio (%) in Marshall Islands in 1999 to that in 2005?
Give a very brief answer. 0.77. What is the ratio of the Gross enrolment ratio (%) in Tanzania in 1999 to that in 2005?
Your answer should be very brief. 0.63. What is the ratio of the Gross enrolment ratio (%) of Czech Republic in 1999 to that in 2006?
Ensure brevity in your answer.  1.02. What is the ratio of the Gross enrolment ratio (%) of Marshall Islands in 1999 to that in 2006?
Your response must be concise. 0.78. What is the ratio of the Gross enrolment ratio (%) of Tanzania in 1999 to that in 2006?
Provide a succinct answer. 0.61. What is the ratio of the Gross enrolment ratio (%) of Austria in 1999 to that in 2007?
Offer a very short reply. 1.02. What is the ratio of the Gross enrolment ratio (%) of Czech Republic in 1999 to that in 2007?
Ensure brevity in your answer.  0.98. What is the ratio of the Gross enrolment ratio (%) of Marshall Islands in 1999 to that in 2007?
Your response must be concise. 0.8. What is the ratio of the Gross enrolment ratio (%) in Tanzania in 1999 to that in 2007?
Your answer should be compact. 0.6. What is the ratio of the Gross enrolment ratio (%) of Czech Republic in 2002 to that in 2003?
Your answer should be compact. 1.03. What is the ratio of the Gross enrolment ratio (%) of Marshall Islands in 2002 to that in 2003?
Offer a terse response. 1.1. What is the ratio of the Gross enrolment ratio (%) in Tanzania in 2002 to that in 2003?
Ensure brevity in your answer.  0.93. What is the ratio of the Gross enrolment ratio (%) of Czech Republic in 2002 to that in 2004?
Your answer should be compact. 1.03. What is the ratio of the Gross enrolment ratio (%) of Tanzania in 2002 to that in 2004?
Ensure brevity in your answer.  0.88. What is the ratio of the Gross enrolment ratio (%) in Czech Republic in 2002 to that in 2005?
Offer a terse response. 1.01. What is the ratio of the Gross enrolment ratio (%) of Marshall Islands in 2002 to that in 2005?
Make the answer very short. 1.04. What is the ratio of the Gross enrolment ratio (%) of Tanzania in 2002 to that in 2005?
Offer a very short reply. 0.85. What is the ratio of the Gross enrolment ratio (%) of Austria in 2002 to that in 2006?
Your response must be concise. 0.99. What is the ratio of the Gross enrolment ratio (%) in Marshall Islands in 2002 to that in 2006?
Ensure brevity in your answer.  1.04. What is the ratio of the Gross enrolment ratio (%) of Tanzania in 2002 to that in 2006?
Your answer should be very brief. 0.82. What is the ratio of the Gross enrolment ratio (%) in Czech Republic in 2002 to that in 2007?
Ensure brevity in your answer.  0.96. What is the ratio of the Gross enrolment ratio (%) in Marshall Islands in 2002 to that in 2007?
Your answer should be very brief. 1.07. What is the ratio of the Gross enrolment ratio (%) of Tanzania in 2002 to that in 2007?
Provide a succinct answer. 0.81. What is the ratio of the Gross enrolment ratio (%) in Czech Republic in 2003 to that in 2004?
Your response must be concise. 1. What is the ratio of the Gross enrolment ratio (%) of Marshall Islands in 2003 to that in 2004?
Your answer should be very brief. 0.91. What is the ratio of the Gross enrolment ratio (%) in Tanzania in 2003 to that in 2004?
Your answer should be compact. 0.95. What is the ratio of the Gross enrolment ratio (%) in Austria in 2003 to that in 2005?
Provide a succinct answer. 0.99. What is the ratio of the Gross enrolment ratio (%) in Czech Republic in 2003 to that in 2005?
Your response must be concise. 0.99. What is the ratio of the Gross enrolment ratio (%) in Marshall Islands in 2003 to that in 2005?
Your answer should be very brief. 0.95. What is the ratio of the Gross enrolment ratio (%) of Tanzania in 2003 to that in 2005?
Your response must be concise. 0.91. What is the ratio of the Gross enrolment ratio (%) of Austria in 2003 to that in 2006?
Ensure brevity in your answer.  0.98. What is the ratio of the Gross enrolment ratio (%) in Czech Republic in 2003 to that in 2006?
Provide a short and direct response. 0.97. What is the ratio of the Gross enrolment ratio (%) of Marshall Islands in 2003 to that in 2006?
Provide a short and direct response. 0.95. What is the ratio of the Gross enrolment ratio (%) in Tanzania in 2003 to that in 2006?
Ensure brevity in your answer.  0.88. What is the ratio of the Gross enrolment ratio (%) of Austria in 2003 to that in 2007?
Offer a terse response. 0.98. What is the ratio of the Gross enrolment ratio (%) in Czech Republic in 2003 to that in 2007?
Provide a short and direct response. 0.94. What is the ratio of the Gross enrolment ratio (%) of Marshall Islands in 2003 to that in 2007?
Keep it short and to the point. 0.98. What is the ratio of the Gross enrolment ratio (%) in Tanzania in 2003 to that in 2007?
Make the answer very short. 0.87. What is the ratio of the Gross enrolment ratio (%) in Marshall Islands in 2004 to that in 2005?
Your answer should be compact. 1.04. What is the ratio of the Gross enrolment ratio (%) of Tanzania in 2004 to that in 2005?
Provide a succinct answer. 0.96. What is the ratio of the Gross enrolment ratio (%) of Austria in 2004 to that in 2006?
Keep it short and to the point. 0.98. What is the ratio of the Gross enrolment ratio (%) in Czech Republic in 2004 to that in 2006?
Give a very brief answer. 0.97. What is the ratio of the Gross enrolment ratio (%) of Marshall Islands in 2004 to that in 2006?
Keep it short and to the point. 1.04. What is the ratio of the Gross enrolment ratio (%) in Tanzania in 2004 to that in 2006?
Provide a succinct answer. 0.93. What is the ratio of the Gross enrolment ratio (%) in Austria in 2004 to that in 2007?
Your response must be concise. 0.98. What is the ratio of the Gross enrolment ratio (%) in Czech Republic in 2004 to that in 2007?
Your answer should be very brief. 0.93. What is the ratio of the Gross enrolment ratio (%) of Marshall Islands in 2004 to that in 2007?
Ensure brevity in your answer.  1.08. What is the ratio of the Gross enrolment ratio (%) of Tanzania in 2004 to that in 2007?
Your answer should be compact. 0.92. What is the ratio of the Gross enrolment ratio (%) of Czech Republic in 2005 to that in 2006?
Offer a terse response. 0.98. What is the ratio of the Gross enrolment ratio (%) in Tanzania in 2005 to that in 2006?
Keep it short and to the point. 0.97. What is the ratio of the Gross enrolment ratio (%) of Austria in 2005 to that in 2007?
Your answer should be very brief. 0.99. What is the ratio of the Gross enrolment ratio (%) in Czech Republic in 2005 to that in 2007?
Give a very brief answer. 0.95. What is the ratio of the Gross enrolment ratio (%) of Marshall Islands in 2005 to that in 2007?
Your response must be concise. 1.03. What is the ratio of the Gross enrolment ratio (%) in Tanzania in 2005 to that in 2007?
Keep it short and to the point. 0.95. What is the ratio of the Gross enrolment ratio (%) in Czech Republic in 2006 to that in 2007?
Offer a very short reply. 0.96. What is the ratio of the Gross enrolment ratio (%) in Marshall Islands in 2006 to that in 2007?
Give a very brief answer. 1.03. What is the ratio of the Gross enrolment ratio (%) of Tanzania in 2006 to that in 2007?
Provide a short and direct response. 0.98. What is the difference between the highest and the second highest Gross enrolment ratio (%) in Austria?
Ensure brevity in your answer.  2.08. What is the difference between the highest and the second highest Gross enrolment ratio (%) of Czech Republic?
Provide a succinct answer. 2.42. What is the difference between the highest and the second highest Gross enrolment ratio (%) in Marshall Islands?
Your answer should be very brief. 0.27. What is the difference between the highest and the second highest Gross enrolment ratio (%) in Tanzania?
Provide a short and direct response. 1.91. What is the difference between the highest and the lowest Gross enrolment ratio (%) in Austria?
Make the answer very short. 4.32. What is the difference between the highest and the lowest Gross enrolment ratio (%) of Czech Republic?
Keep it short and to the point. 6.93. What is the difference between the highest and the lowest Gross enrolment ratio (%) in Marshall Islands?
Your answer should be very brief. 30.93. What is the difference between the highest and the lowest Gross enrolment ratio (%) of Tanzania?
Keep it short and to the point. 43.61. 